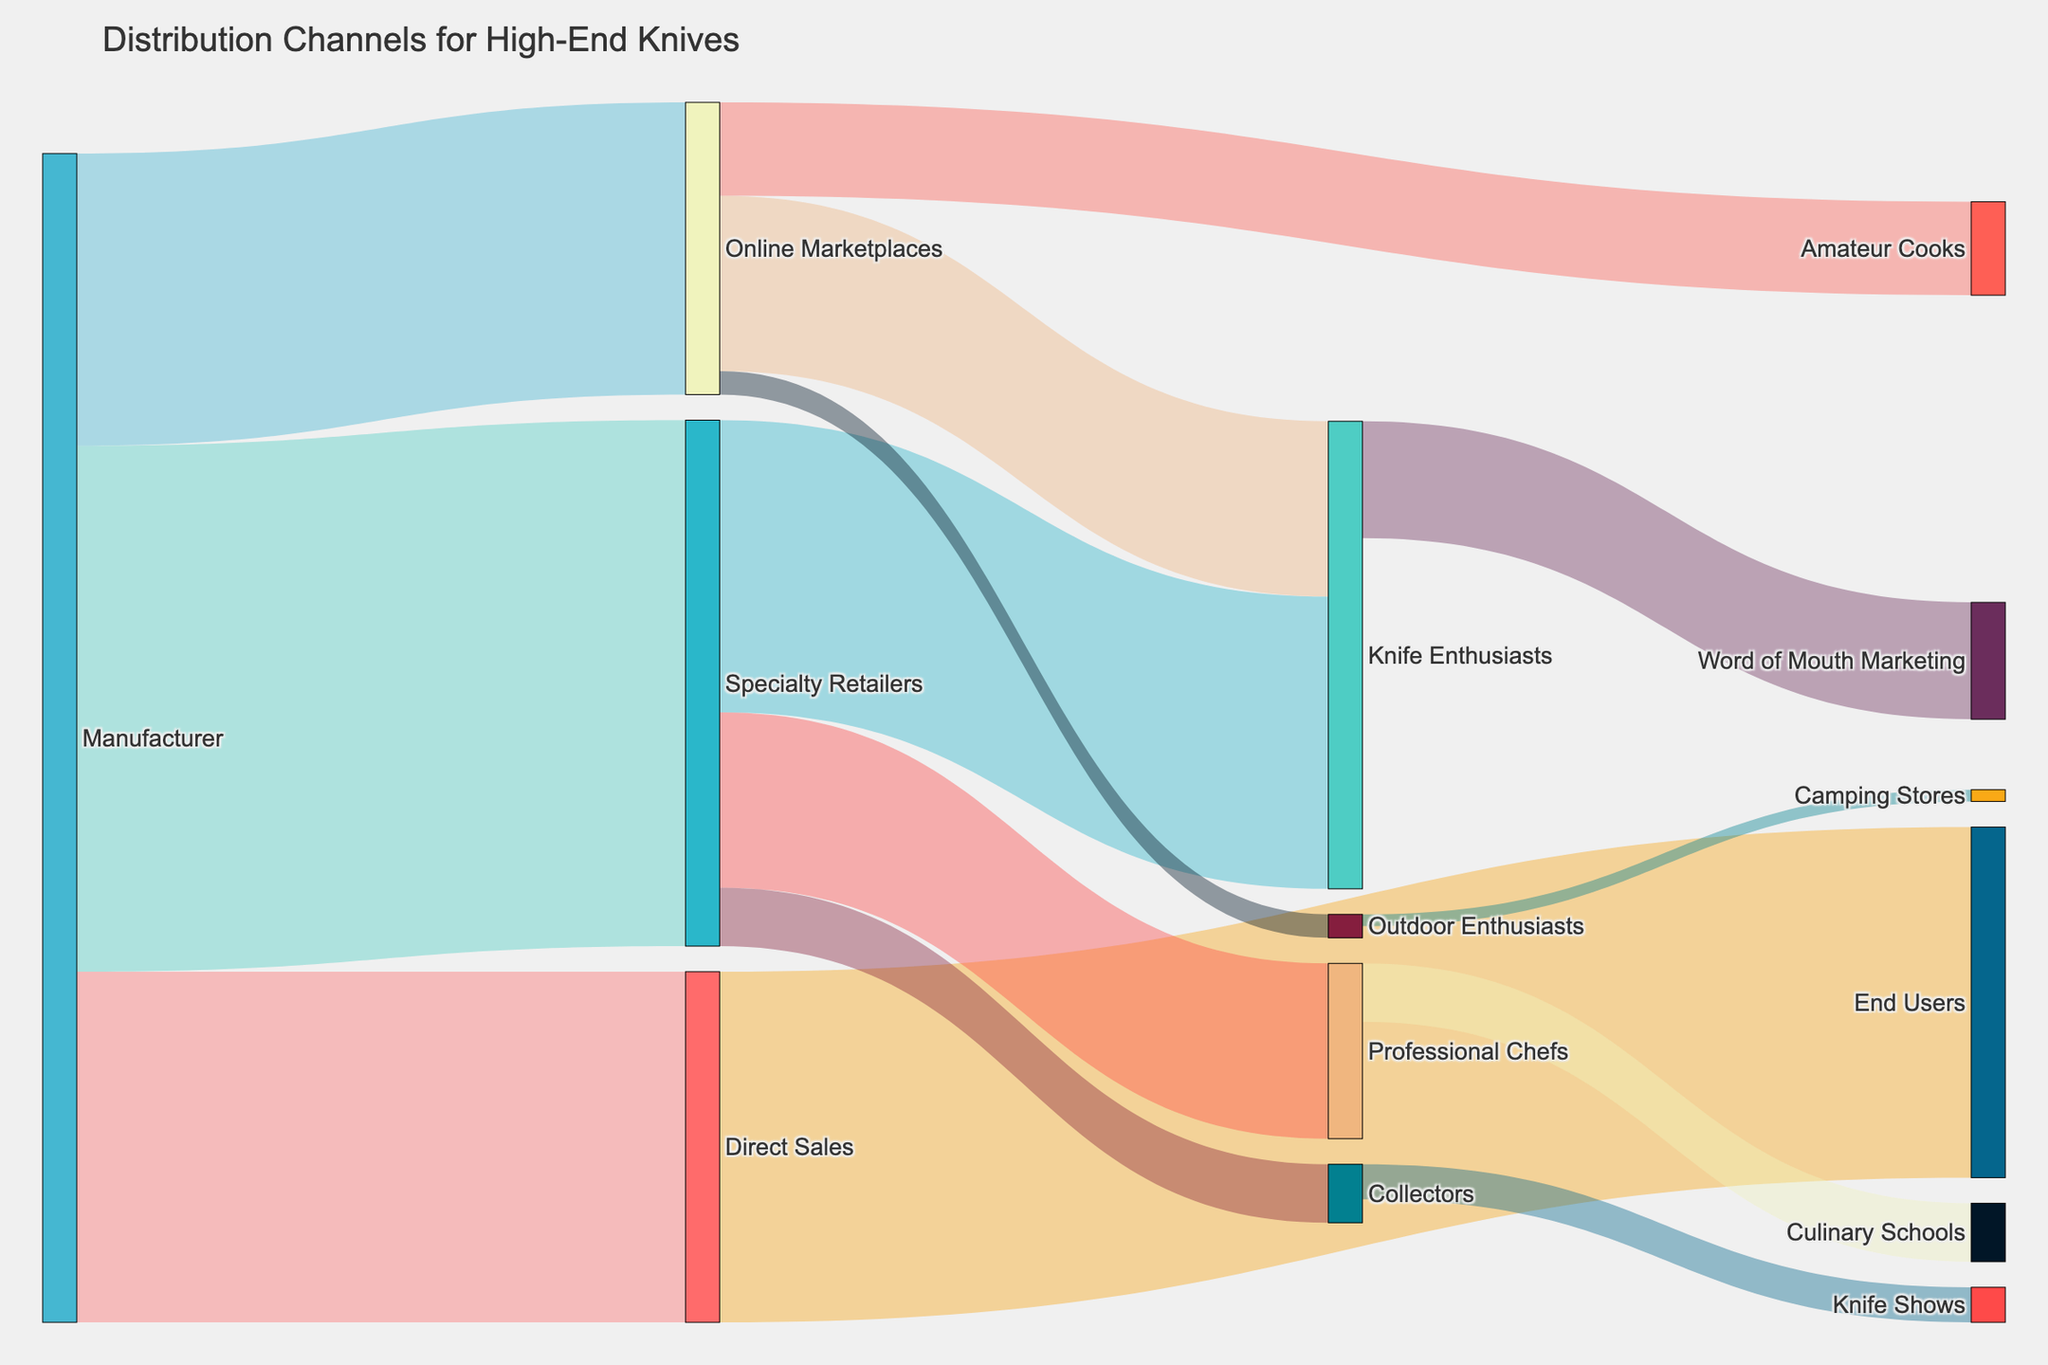What's the title of the diagram? The title is displayed at the top of the Sankey Diagram and gives an overview of the subject matter.
Answer: Distribution Channels for High-End Knives Which retailer has the highest number of units distributed from the manufacturer? Look at the width of the flows originating from the "Manufacturer." The widest flow goes to "Specialty Retailers" with a value of 45 units.
Answer: Specialty Retailers What is the total number of units that reach the end users directly and indirectly? Add the units that go directly to "End Users" from "Direct Sales" (30) and units reaching different end users from "Specialty Retailers" and "Online Marketplaces": Knife Enthusiasts (40), Professional Chefs (20), Collectors (5), Amateur Cooks (8), and Outdoor Enthusiasts (2) summing up to 105 units.
Answer: 105 Which distribution channel connects the manufacturer to collectors? Look at the path linking the "Manufacturer" and "Collectors". The flow goes from "Manufacturer" to "Specialty Retailers" and then to "Collectors".
Answer: Specialty Retailers How many units are distributed through word-of-mouth marketing from knife enthusiasts? Identify the flow stemming from "Knife Enthusiasts" to "Word of Mouth Marketing", which shows 10 units.
Answer: 10 Compare the number of units going from specialty retailers to knife enthusiasts with those going from online marketplaces to amateur cooks. Which is higher? Find the flows from "Specialty Retailers" to "Knife Enthusiasts" (25 units) and from "Online Marketplaces" to "Amateur Cooks" (8 units). Compare these two values.
Answer: Knife enthusiasts (25 units) is higher What fraction of the units sent from online marketplaces ends up with amateur cooks? Identify the flow from "Online Marketplaces" to "Amateur Cooks" (8 units) and divide by the total units from "Online Marketplaces" (25 units). The fraction is 8/25.
Answer: 8/25 How many units are involved in secondary distribution from specialty retailers? Sum the units flowing from "Specialty Retailers" to different groups: Knife Enthusiasts (25), Professional Chefs (15), and Collectors (5), resulting in total 45 units.
Answer: 45 What's the percentage of units distributed to professional chefs compared to the total units from all channels? Calculate the percentage of units to "Professional Chefs" (15 units) out of the total units distributed (100 units): (15/100)*100%.
Answer: 15% Which path has the smallest value? Identify the flow with the smallest width, which goes from "Online Marketplaces" to "Outdoor Enthusiasts" with a value of 2 units.
Answer: Online Marketplaces to Outdoor Enthusiasts 